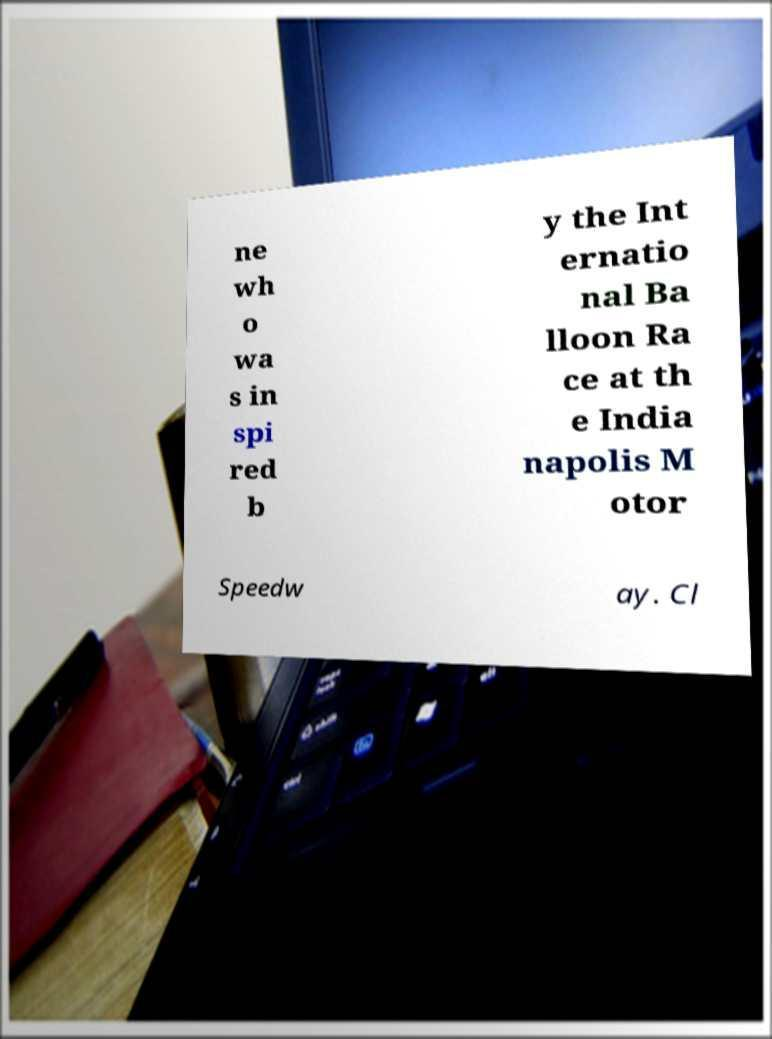Please identify and transcribe the text found in this image. ne wh o wa s in spi red b y the Int ernatio nal Ba lloon Ra ce at th e India napolis M otor Speedw ay. Cl 